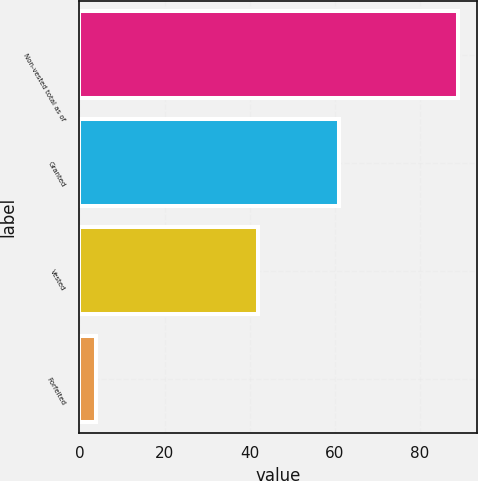Convert chart. <chart><loc_0><loc_0><loc_500><loc_500><bar_chart><fcel>Non-vested total as of<fcel>Granted<fcel>Vested<fcel>Forfeited<nl><fcel>89<fcel>61<fcel>42<fcel>4<nl></chart> 